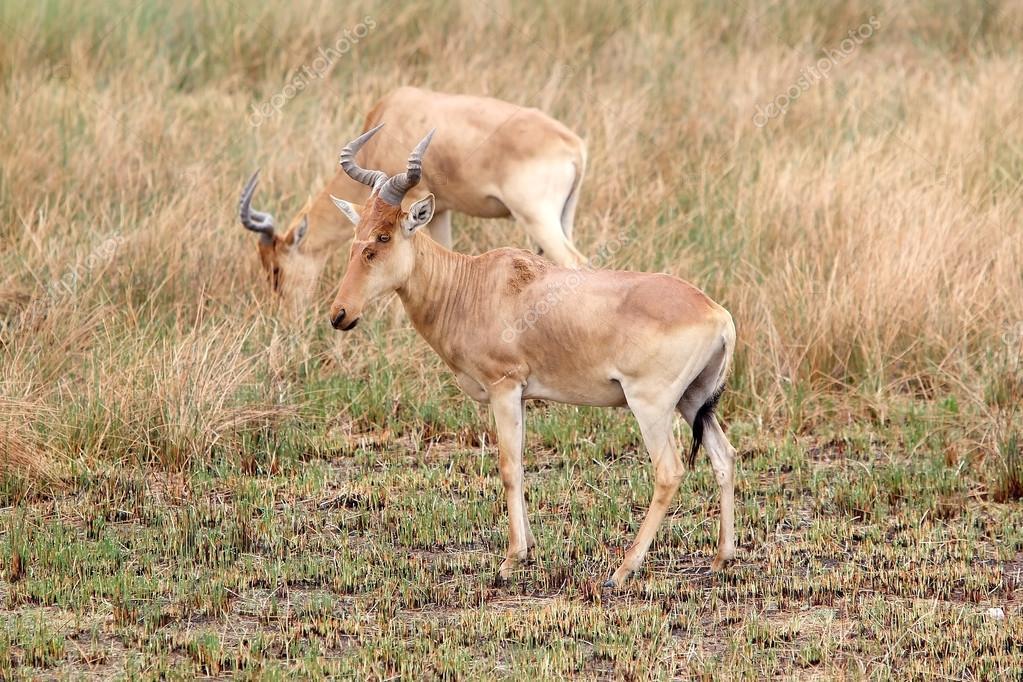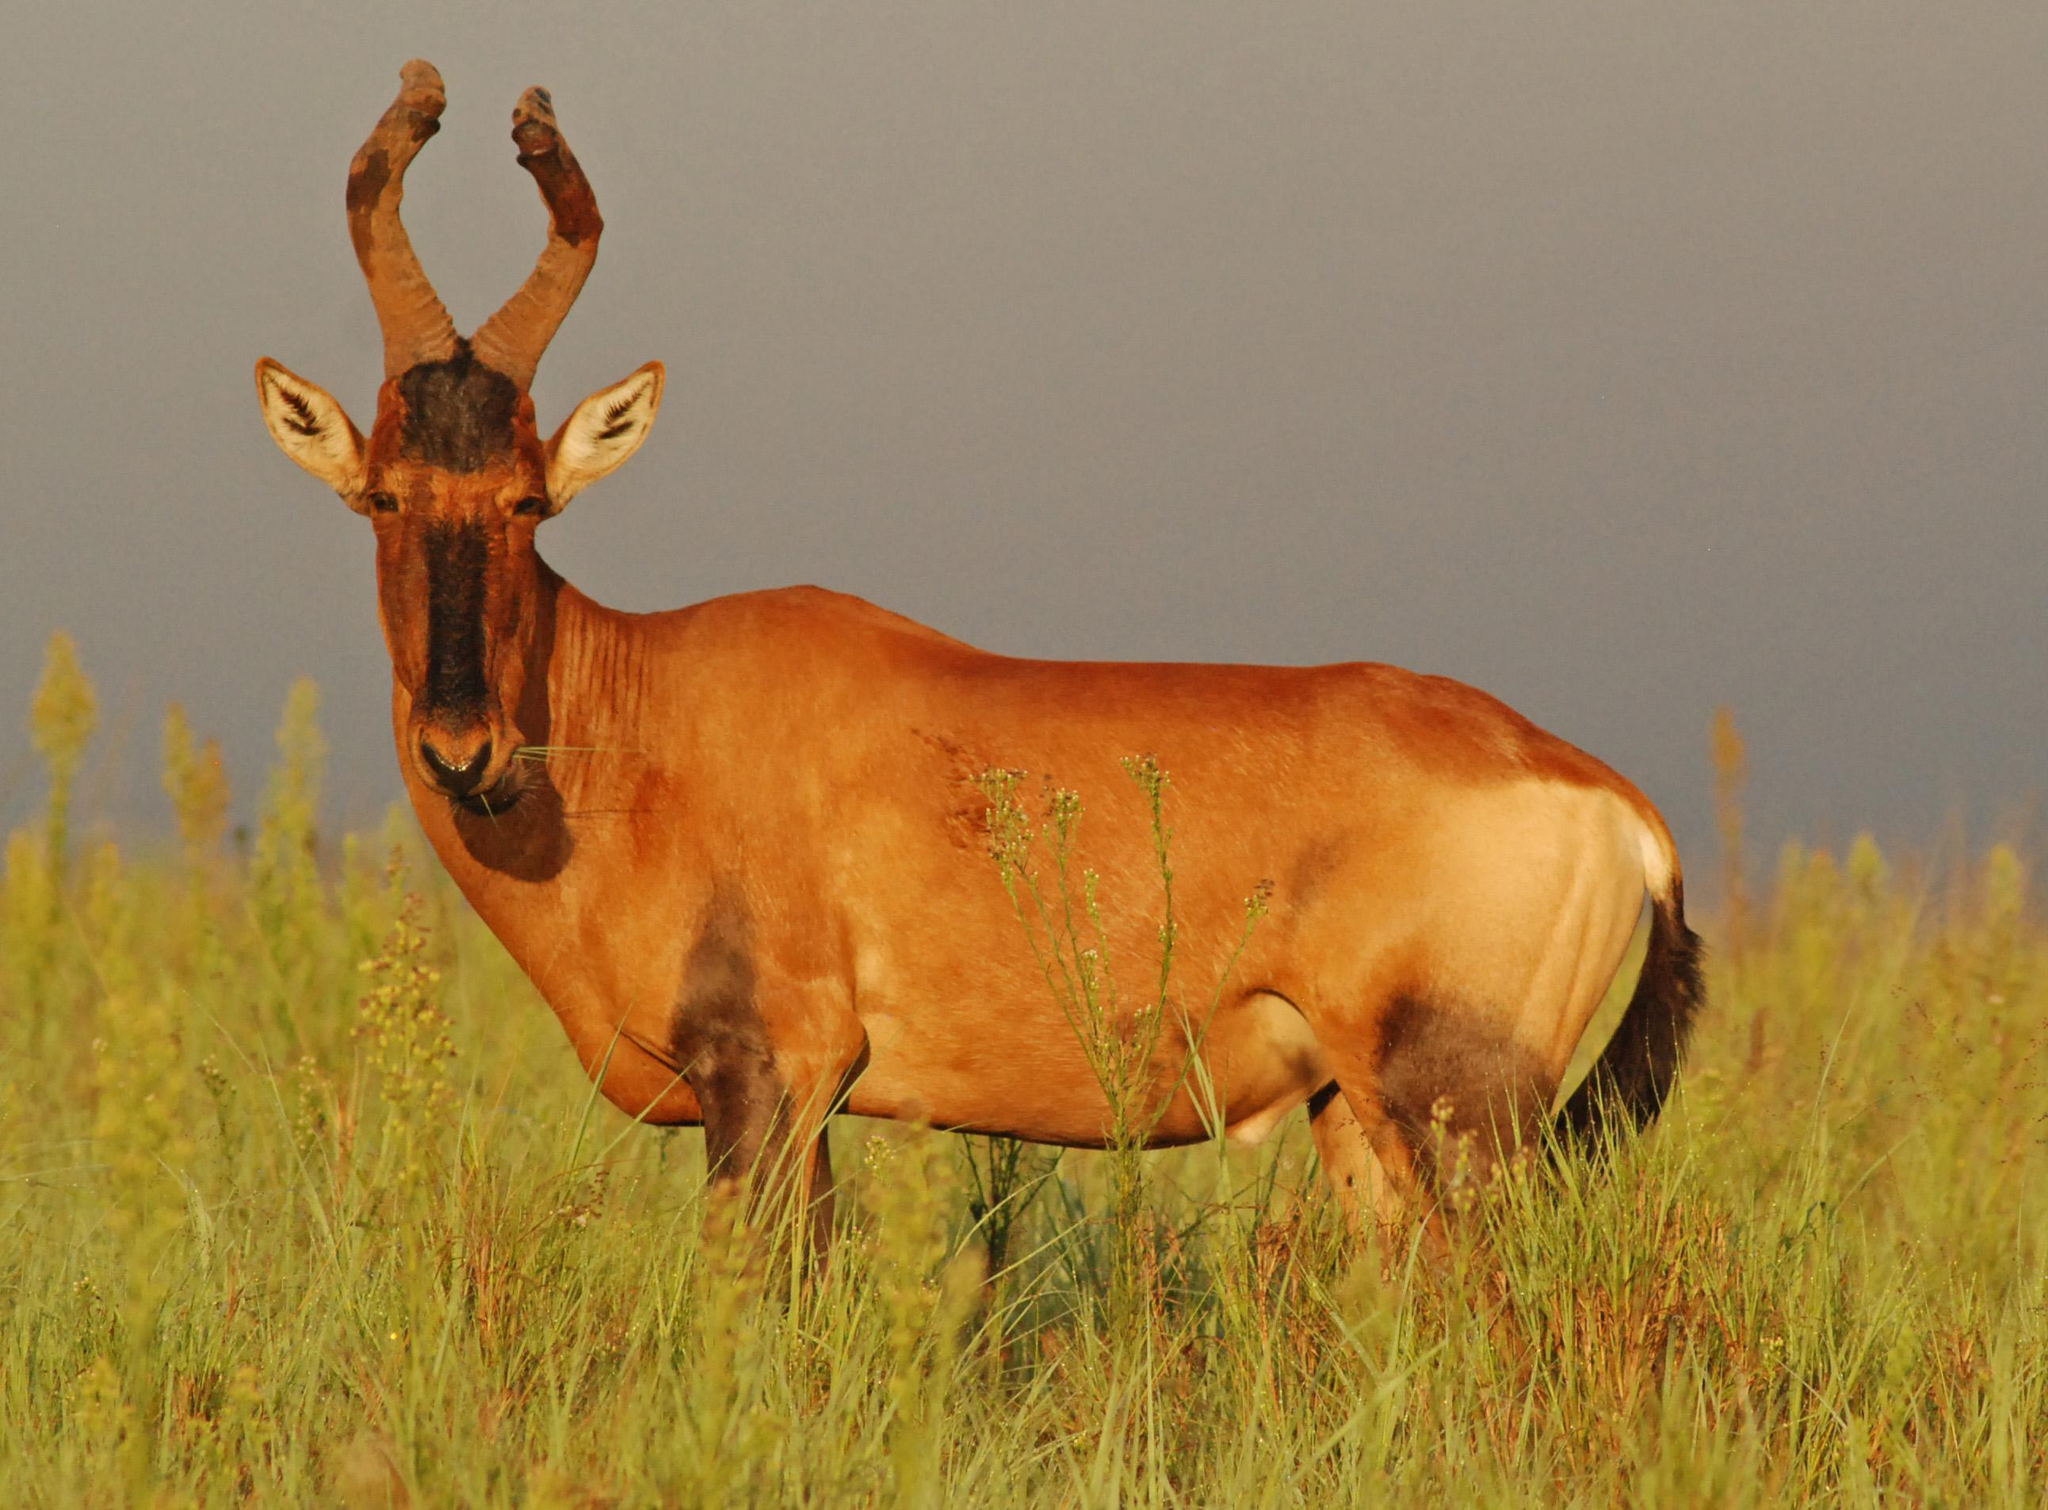The first image is the image on the left, the second image is the image on the right. Considering the images on both sides, is "Each image contains only one horned animal, and the animals on the left and right are gazing in the same direction." valid? Answer yes or no. No. The first image is the image on the left, the second image is the image on the right. Analyze the images presented: Is the assertion "The animal in the left image is pointed to the right." valid? Answer yes or no. No. 